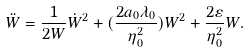<formula> <loc_0><loc_0><loc_500><loc_500>\ddot { W } = \frac { 1 } { 2 W } \dot { W } ^ { 2 } + ( \frac { 2 a _ { 0 } \lambda _ { 0 } } { \eta _ { 0 } ^ { 2 } } ) W ^ { 2 } + \frac { 2 \varepsilon } { \eta _ { 0 } ^ { 2 } } W .</formula> 